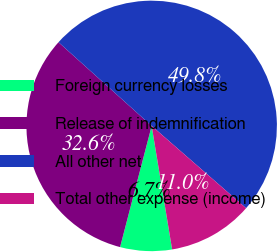<chart> <loc_0><loc_0><loc_500><loc_500><pie_chart><fcel>Foreign currency losses<fcel>Release of indemnification<fcel>All other net<fcel>Total other expense (income)<nl><fcel>6.67%<fcel>32.59%<fcel>49.76%<fcel>10.98%<nl></chart> 